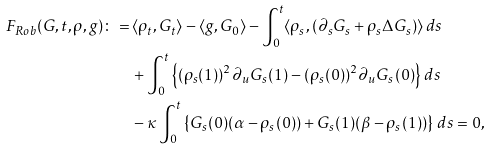<formula> <loc_0><loc_0><loc_500><loc_500>F _ { R o b } ( G , t , \rho , g ) \colon = \, & \langle \rho _ { t } , G _ { t } \rangle - \langle g , G _ { 0 } \rangle - \int _ { 0 } ^ { t } \langle \rho _ { s } , ( \partial _ { s } G _ { s } + \rho _ { s } \Delta G _ { s } ) \rangle \, d s \\ & + \int ^ { t } _ { 0 } \left \{ ( \rho _ { s } ( 1 ) ) ^ { 2 } \partial _ { u } G _ { s } ( 1 ) - ( \rho _ { s } ( 0 ) ) ^ { 2 } \partial _ { u } G _ { s } ( 0 ) \right \} \, d s \\ & - \kappa \int ^ { t } _ { 0 } \left \{ G _ { s } ( 0 ) ( \alpha - \rho _ { s } ( 0 ) ) + G _ { s } ( 1 ) ( \beta - \rho _ { s } ( 1 ) ) \right \} \, d s = 0 ,</formula> 